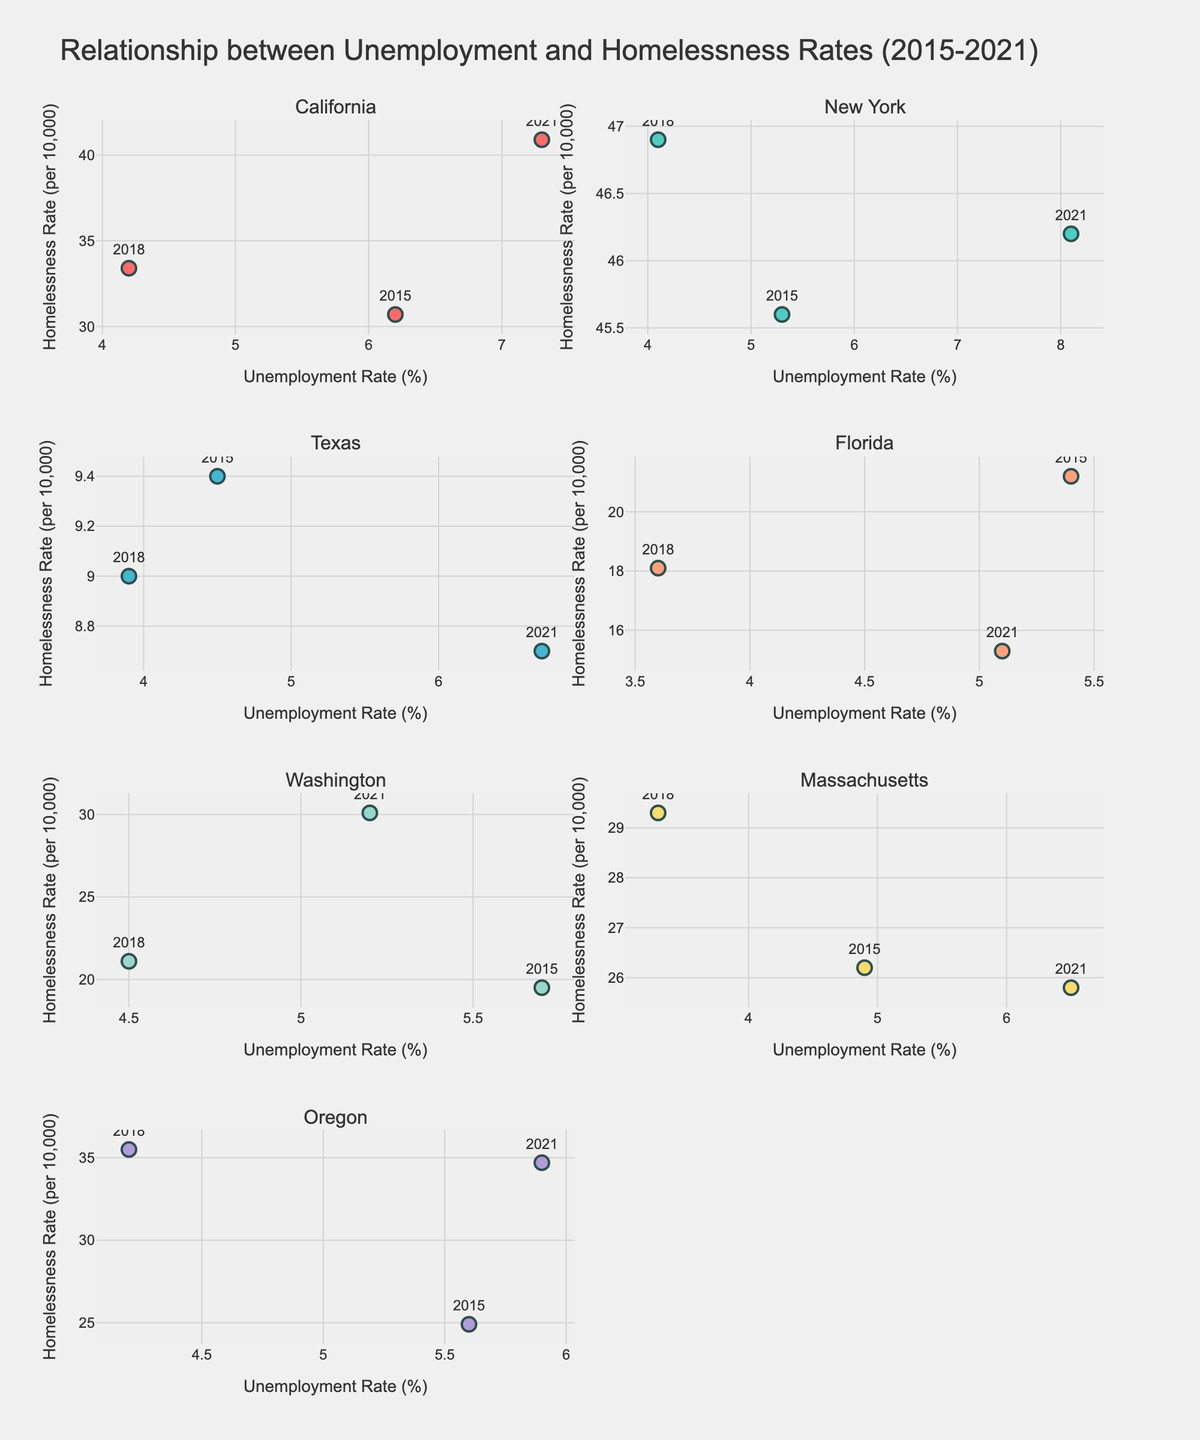What's the title of the figure? The figure's title is written prominently at the top of the plot, showing the overall theme being visualized.
Answer: Relationship between Unemployment and Homelessness Rates (2015-2021) What are the x-axis and y-axis labels for each subplot? Each subplot has labels for its respective x-axis and y-axis which help understand what is being plotted. The x-axis is labeled "Unemployment Rate (%)" and the y-axis is labeled "Homelessness Rate (per 10,000)" in all subplots.
Answer: Unemployment Rate (%) and Homelessness Rate (per 10,000) How many states are depicted in the figure? The figure consists of subplots for different states, with each state's data being showcased in a separate subplot. The subplot titles give away the number of represented states.
Answer: 7 Which state has the highest homelessness rate in 2021? Look at the data points for 2021 in each state subplot and identify the one with the highest y-value (Homelessness Rate). New York's data in 2021 shows the highest position along the y-axis.
Answer: New York Did Texas experience an increase or decrease in homelessness rate from 2015 to 2021? Evaluate the trend of Texas’s data points from 2015 to 2021 by observing their positions on the y-axis. Texas has a slight decrease from 9.4 to 8.7 homelessness rate over these years.
Answer: Decrease Compare the unemployment rate for California and New York in 2021. Which state had a higher unemployment rate? Check the 2021 data points for both California and New York subplots and compare their x-values. California shows an unemployment rate of 7.3%, while New York shows 8.1%.
Answer: New York What is the general trend of homelessness rates in Oregon between 2015 and 2021? Observe the positions of the data points for Oregon over time and whether they generally move up or down on the y-axis. Oregon’s homelessness rate increases from 2015 to 2018 and slightly decreases in 2021 but remains higher than 2015.
Answer: Increase What is the average homelessness rate in Florida over the years provided? Extract the homelessness rates of Florida’s data points (21.2, 18.1, 15.3), add them together, and divide by the number of years (3).
Answer: (21.2 + 18.1 + 15.3) / 3 = 18.2 Which year had the lowest unemployment rate in Massachusetts? Look at the Massachusetts subplot and identify the year with the lowest x-value. The lowest unemployment rate in Massachusetts is in 2018, with a value of 3.3%.
Answer: 2018 Does higher unemployment generally correspond to higher homelessness across most states? This requires looking at the pattern of the data points across all subplots and identifying whether higher x-values consistently have higher y-values, indicating a positive relationship. Although not always linear, generally increased unemployment can be correlated with higher homelessness in most subplots.
Answer: Generally, yes 